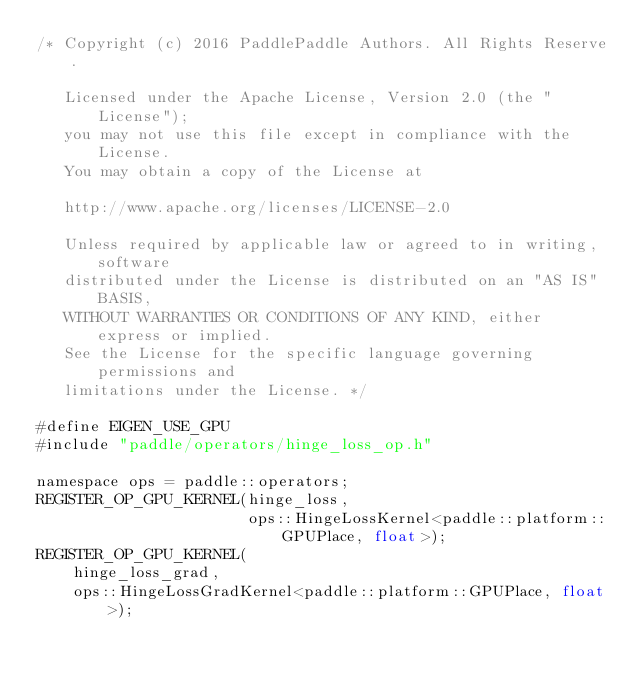<code> <loc_0><loc_0><loc_500><loc_500><_Cuda_>/* Copyright (c) 2016 PaddlePaddle Authors. All Rights Reserve.

   Licensed under the Apache License, Version 2.0 (the "License");
   you may not use this file except in compliance with the License.
   You may obtain a copy of the License at

   http://www.apache.org/licenses/LICENSE-2.0

   Unless required by applicable law or agreed to in writing, software
   distributed under the License is distributed on an "AS IS" BASIS,
   WITHOUT WARRANTIES OR CONDITIONS OF ANY KIND, either express or implied.
   See the License for the specific language governing permissions and
   limitations under the License. */

#define EIGEN_USE_GPU
#include "paddle/operators/hinge_loss_op.h"

namespace ops = paddle::operators;
REGISTER_OP_GPU_KERNEL(hinge_loss,
                       ops::HingeLossKernel<paddle::platform::GPUPlace, float>);
REGISTER_OP_GPU_KERNEL(
    hinge_loss_grad,
    ops::HingeLossGradKernel<paddle::platform::GPUPlace, float>);
</code> 